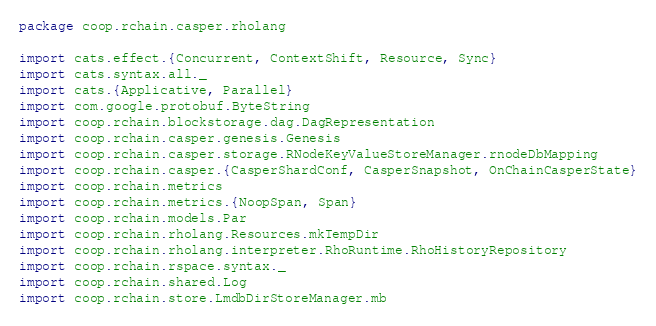Convert code to text. <code><loc_0><loc_0><loc_500><loc_500><_Scala_>package coop.rchain.casper.rholang

import cats.effect.{Concurrent, ContextShift, Resource, Sync}
import cats.syntax.all._
import cats.{Applicative, Parallel}
import com.google.protobuf.ByteString
import coop.rchain.blockstorage.dag.DagRepresentation
import coop.rchain.casper.genesis.Genesis
import coop.rchain.casper.storage.RNodeKeyValueStoreManager.rnodeDbMapping
import coop.rchain.casper.{CasperShardConf, CasperSnapshot, OnChainCasperState}
import coop.rchain.metrics
import coop.rchain.metrics.{NoopSpan, Span}
import coop.rchain.models.Par
import coop.rchain.rholang.Resources.mkTempDir
import coop.rchain.rholang.interpreter.RhoRuntime.RhoHistoryRepository
import coop.rchain.rspace.syntax._
import coop.rchain.shared.Log
import coop.rchain.store.LmdbDirStoreManager.mb</code> 